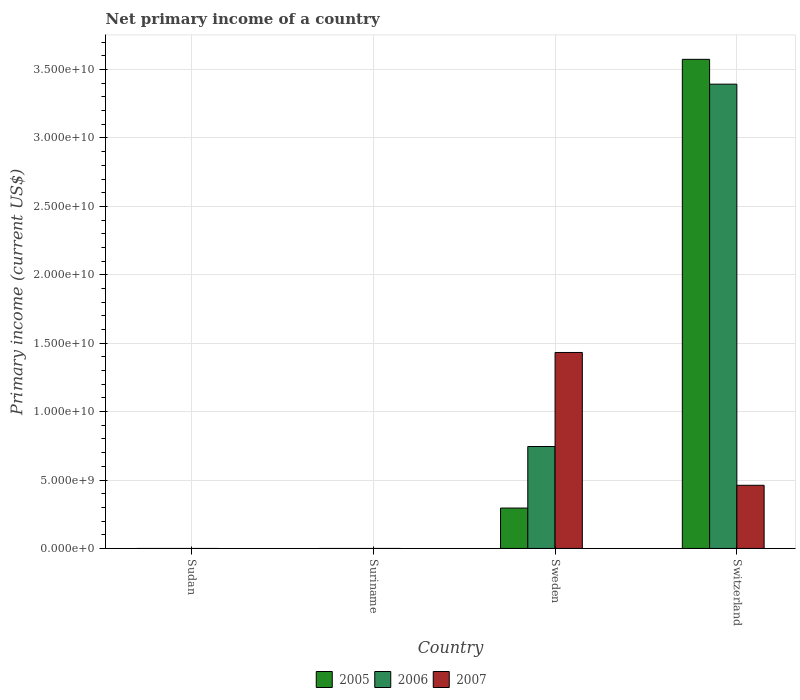In how many cases, is the number of bars for a given country not equal to the number of legend labels?
Ensure brevity in your answer.  2. What is the primary income in 2005 in Sweden?
Keep it short and to the point. 2.95e+09. Across all countries, what is the maximum primary income in 2005?
Ensure brevity in your answer.  3.57e+1. Across all countries, what is the minimum primary income in 2006?
Provide a short and direct response. 0. What is the total primary income in 2005 in the graph?
Make the answer very short. 3.87e+1. What is the difference between the primary income in 2005 in Sweden and that in Switzerland?
Provide a succinct answer. -3.28e+1. What is the difference between the primary income in 2006 in Switzerland and the primary income in 2005 in Sweden?
Offer a very short reply. 3.10e+1. What is the average primary income in 2006 per country?
Offer a terse response. 1.03e+1. What is the difference between the primary income of/in 2006 and primary income of/in 2005 in Switzerland?
Provide a short and direct response. -1.82e+09. In how many countries, is the primary income in 2006 greater than 8000000000 US$?
Your response must be concise. 1. What is the ratio of the primary income in 2005 in Sweden to that in Switzerland?
Offer a terse response. 0.08. Is the primary income in 2007 in Sweden less than that in Switzerland?
Your response must be concise. No. Is the difference between the primary income in 2006 in Sweden and Switzerland greater than the difference between the primary income in 2005 in Sweden and Switzerland?
Make the answer very short. Yes. What is the difference between the highest and the lowest primary income in 2007?
Offer a very short reply. 1.43e+1. Is it the case that in every country, the sum of the primary income in 2007 and primary income in 2006 is greater than the primary income in 2005?
Give a very brief answer. No. How many bars are there?
Provide a succinct answer. 6. Are all the bars in the graph horizontal?
Your answer should be very brief. No. How many countries are there in the graph?
Make the answer very short. 4. What is the difference between two consecutive major ticks on the Y-axis?
Provide a short and direct response. 5.00e+09. Are the values on the major ticks of Y-axis written in scientific E-notation?
Make the answer very short. Yes. Does the graph contain any zero values?
Keep it short and to the point. Yes. Where does the legend appear in the graph?
Your answer should be compact. Bottom center. How many legend labels are there?
Your answer should be very brief. 3. How are the legend labels stacked?
Ensure brevity in your answer.  Horizontal. What is the title of the graph?
Your response must be concise. Net primary income of a country. What is the label or title of the X-axis?
Provide a succinct answer. Country. What is the label or title of the Y-axis?
Offer a very short reply. Primary income (current US$). What is the Primary income (current US$) in 2005 in Sudan?
Give a very brief answer. 0. What is the Primary income (current US$) in 2007 in Sudan?
Your answer should be compact. 0. What is the Primary income (current US$) in 2006 in Suriname?
Provide a short and direct response. 0. What is the Primary income (current US$) of 2007 in Suriname?
Offer a terse response. 0. What is the Primary income (current US$) in 2005 in Sweden?
Provide a short and direct response. 2.95e+09. What is the Primary income (current US$) of 2006 in Sweden?
Provide a short and direct response. 7.45e+09. What is the Primary income (current US$) of 2007 in Sweden?
Your response must be concise. 1.43e+1. What is the Primary income (current US$) in 2005 in Switzerland?
Your answer should be very brief. 3.57e+1. What is the Primary income (current US$) in 2006 in Switzerland?
Your answer should be compact. 3.39e+1. What is the Primary income (current US$) of 2007 in Switzerland?
Offer a terse response. 4.62e+09. Across all countries, what is the maximum Primary income (current US$) in 2005?
Provide a short and direct response. 3.57e+1. Across all countries, what is the maximum Primary income (current US$) in 2006?
Your answer should be compact. 3.39e+1. Across all countries, what is the maximum Primary income (current US$) in 2007?
Offer a very short reply. 1.43e+1. Across all countries, what is the minimum Primary income (current US$) of 2005?
Your answer should be very brief. 0. What is the total Primary income (current US$) of 2005 in the graph?
Keep it short and to the point. 3.87e+1. What is the total Primary income (current US$) of 2006 in the graph?
Give a very brief answer. 4.14e+1. What is the total Primary income (current US$) in 2007 in the graph?
Give a very brief answer. 1.89e+1. What is the difference between the Primary income (current US$) of 2005 in Sweden and that in Switzerland?
Your response must be concise. -3.28e+1. What is the difference between the Primary income (current US$) in 2006 in Sweden and that in Switzerland?
Offer a terse response. -2.65e+1. What is the difference between the Primary income (current US$) in 2007 in Sweden and that in Switzerland?
Your response must be concise. 9.71e+09. What is the difference between the Primary income (current US$) in 2005 in Sweden and the Primary income (current US$) in 2006 in Switzerland?
Your answer should be compact. -3.10e+1. What is the difference between the Primary income (current US$) of 2005 in Sweden and the Primary income (current US$) of 2007 in Switzerland?
Provide a succinct answer. -1.66e+09. What is the difference between the Primary income (current US$) in 2006 in Sweden and the Primary income (current US$) in 2007 in Switzerland?
Give a very brief answer. 2.83e+09. What is the average Primary income (current US$) of 2005 per country?
Provide a succinct answer. 9.67e+09. What is the average Primary income (current US$) in 2006 per country?
Offer a terse response. 1.03e+1. What is the average Primary income (current US$) of 2007 per country?
Provide a short and direct response. 4.73e+09. What is the difference between the Primary income (current US$) in 2005 and Primary income (current US$) in 2006 in Sweden?
Provide a succinct answer. -4.50e+09. What is the difference between the Primary income (current US$) of 2005 and Primary income (current US$) of 2007 in Sweden?
Ensure brevity in your answer.  -1.14e+1. What is the difference between the Primary income (current US$) in 2006 and Primary income (current US$) in 2007 in Sweden?
Offer a very short reply. -6.87e+09. What is the difference between the Primary income (current US$) of 2005 and Primary income (current US$) of 2006 in Switzerland?
Your answer should be very brief. 1.82e+09. What is the difference between the Primary income (current US$) in 2005 and Primary income (current US$) in 2007 in Switzerland?
Make the answer very short. 3.11e+1. What is the difference between the Primary income (current US$) of 2006 and Primary income (current US$) of 2007 in Switzerland?
Your answer should be very brief. 2.93e+1. What is the ratio of the Primary income (current US$) in 2005 in Sweden to that in Switzerland?
Ensure brevity in your answer.  0.08. What is the ratio of the Primary income (current US$) of 2006 in Sweden to that in Switzerland?
Give a very brief answer. 0.22. What is the ratio of the Primary income (current US$) in 2007 in Sweden to that in Switzerland?
Give a very brief answer. 3.1. What is the difference between the highest and the lowest Primary income (current US$) of 2005?
Give a very brief answer. 3.57e+1. What is the difference between the highest and the lowest Primary income (current US$) in 2006?
Provide a short and direct response. 3.39e+1. What is the difference between the highest and the lowest Primary income (current US$) of 2007?
Ensure brevity in your answer.  1.43e+1. 